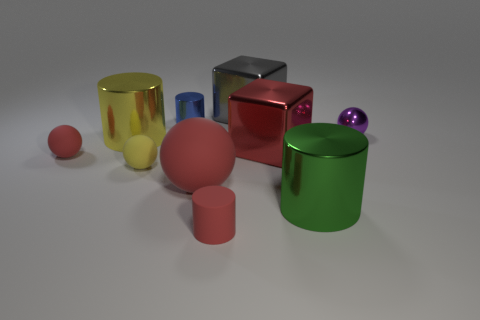Subtract all gray cylinders. Subtract all green spheres. How many cylinders are left? 4 Subtract all gray cubes. How many blue balls are left? 0 Add 6 things. How many small purples exist? 0 Subtract all tiny shiny cylinders. Subtract all matte cylinders. How many objects are left? 8 Add 1 blue shiny cylinders. How many blue shiny cylinders are left? 2 Add 6 tiny blue metallic cylinders. How many tiny blue metallic cylinders exist? 7 Subtract all red balls. How many balls are left? 2 Subtract all big yellow metallic cylinders. How many cylinders are left? 3 Subtract 1 red blocks. How many objects are left? 9 How many red spheres must be subtracted to get 1 red spheres? 1 